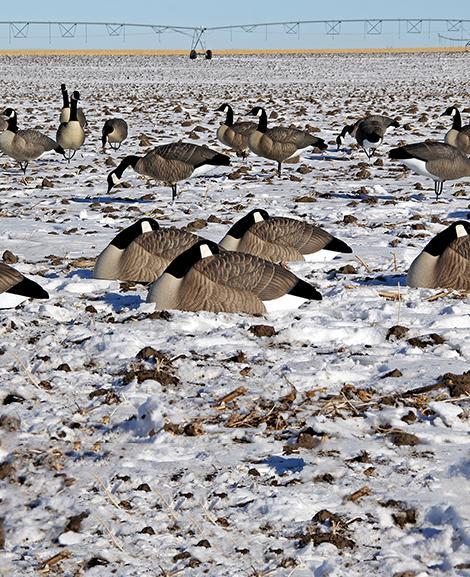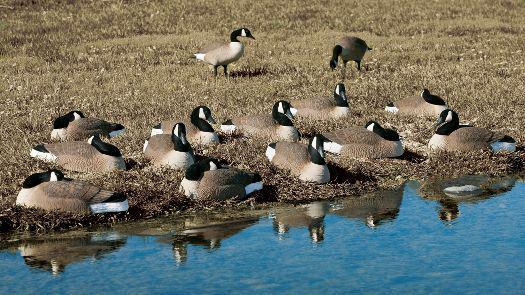The first image is the image on the left, the second image is the image on the right. Considering the images on both sides, is "The right image features a duck decoy on shredded material, and no image contains more than six decoys in the foreground." valid? Answer yes or no. No. The first image is the image on the left, the second image is the image on the right. For the images shown, is this caption "The birds in at least one of the images are near a tree surrounded area." true? Answer yes or no. No. 